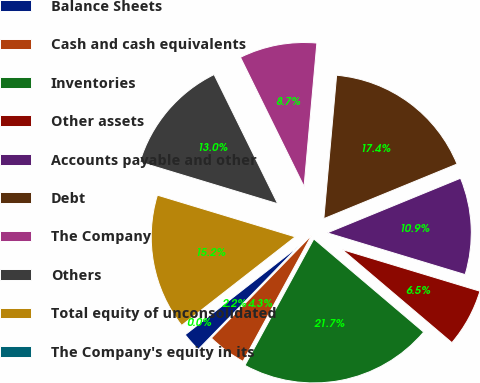Convert chart to OTSL. <chart><loc_0><loc_0><loc_500><loc_500><pie_chart><fcel>Balance Sheets<fcel>Cash and cash equivalents<fcel>Inventories<fcel>Other assets<fcel>Accounts payable and other<fcel>Debt<fcel>The Company<fcel>Others<fcel>Total equity of unconsolidated<fcel>The Company's equity in its<nl><fcel>2.17%<fcel>4.35%<fcel>21.74%<fcel>6.52%<fcel>10.87%<fcel>17.39%<fcel>8.7%<fcel>13.04%<fcel>15.22%<fcel>0.0%<nl></chart> 